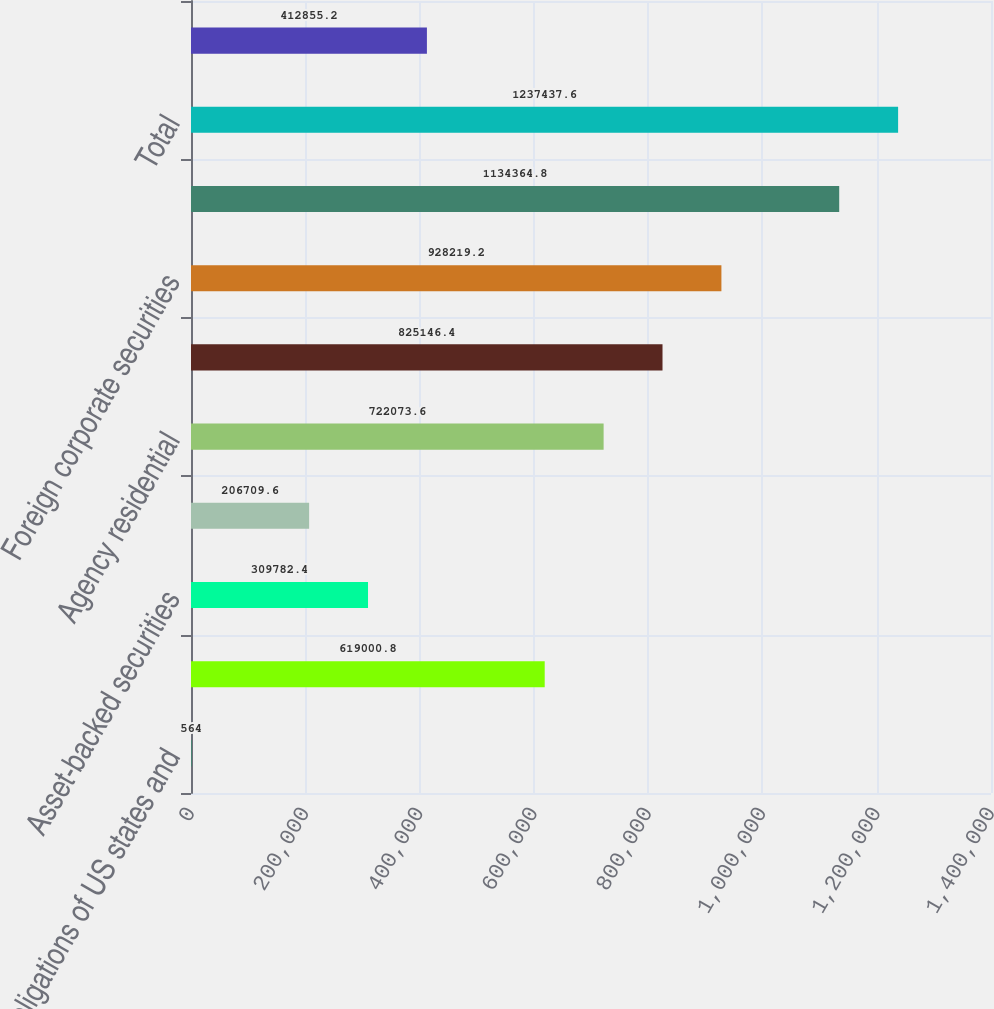<chart> <loc_0><loc_0><loc_500><loc_500><bar_chart><fcel>Obligations of US states and<fcel>Corporate securities<fcel>Asset-backed securities<fcel>Commercial<fcel>Agency residential<fcel>Foreign government securities<fcel>Foreign corporate securities<fcel>Total fixed maturity<fcel>Total<fcel>Due in one year or less<nl><fcel>564<fcel>619001<fcel>309782<fcel>206710<fcel>722074<fcel>825146<fcel>928219<fcel>1.13436e+06<fcel>1.23744e+06<fcel>412855<nl></chart> 